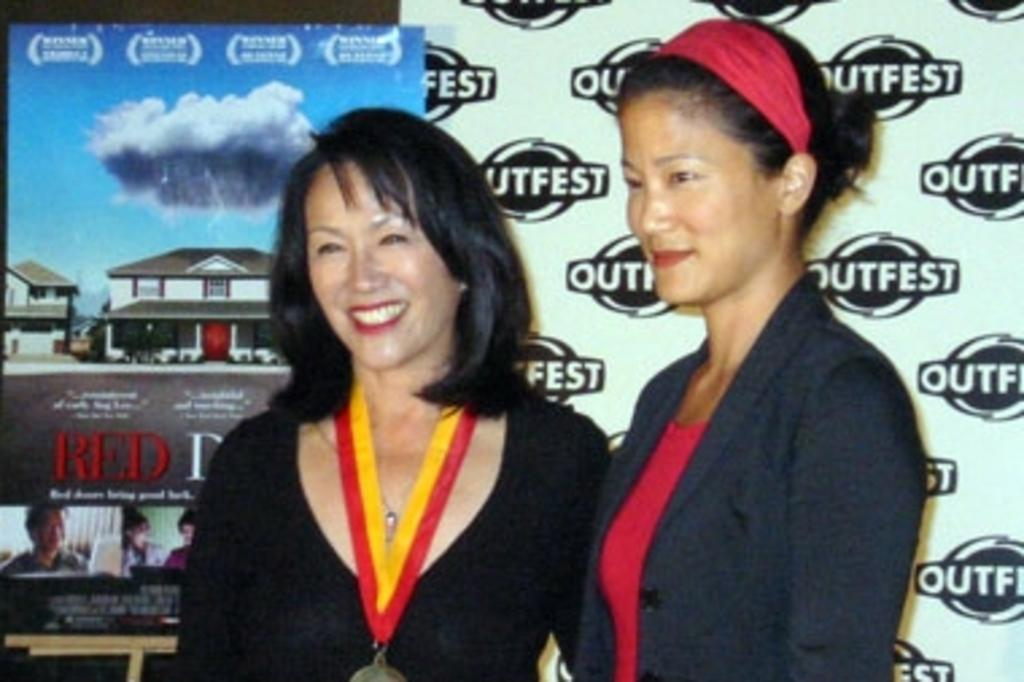Who is in the front of the image? There are women standing in the front of the image. What are the women doing in the image? The women are smiling. What can be seen in the background of the image? There are banners in the background of the image. What is written or depicted on the banners? The banners have text and images on them. How much dust can be seen on the women's clothes in the image? There is no dust visible on the women's clothes in the image. What type of spark is emitted from the banners in the image? There are no sparks present in the image; the banners have text and images on them. 